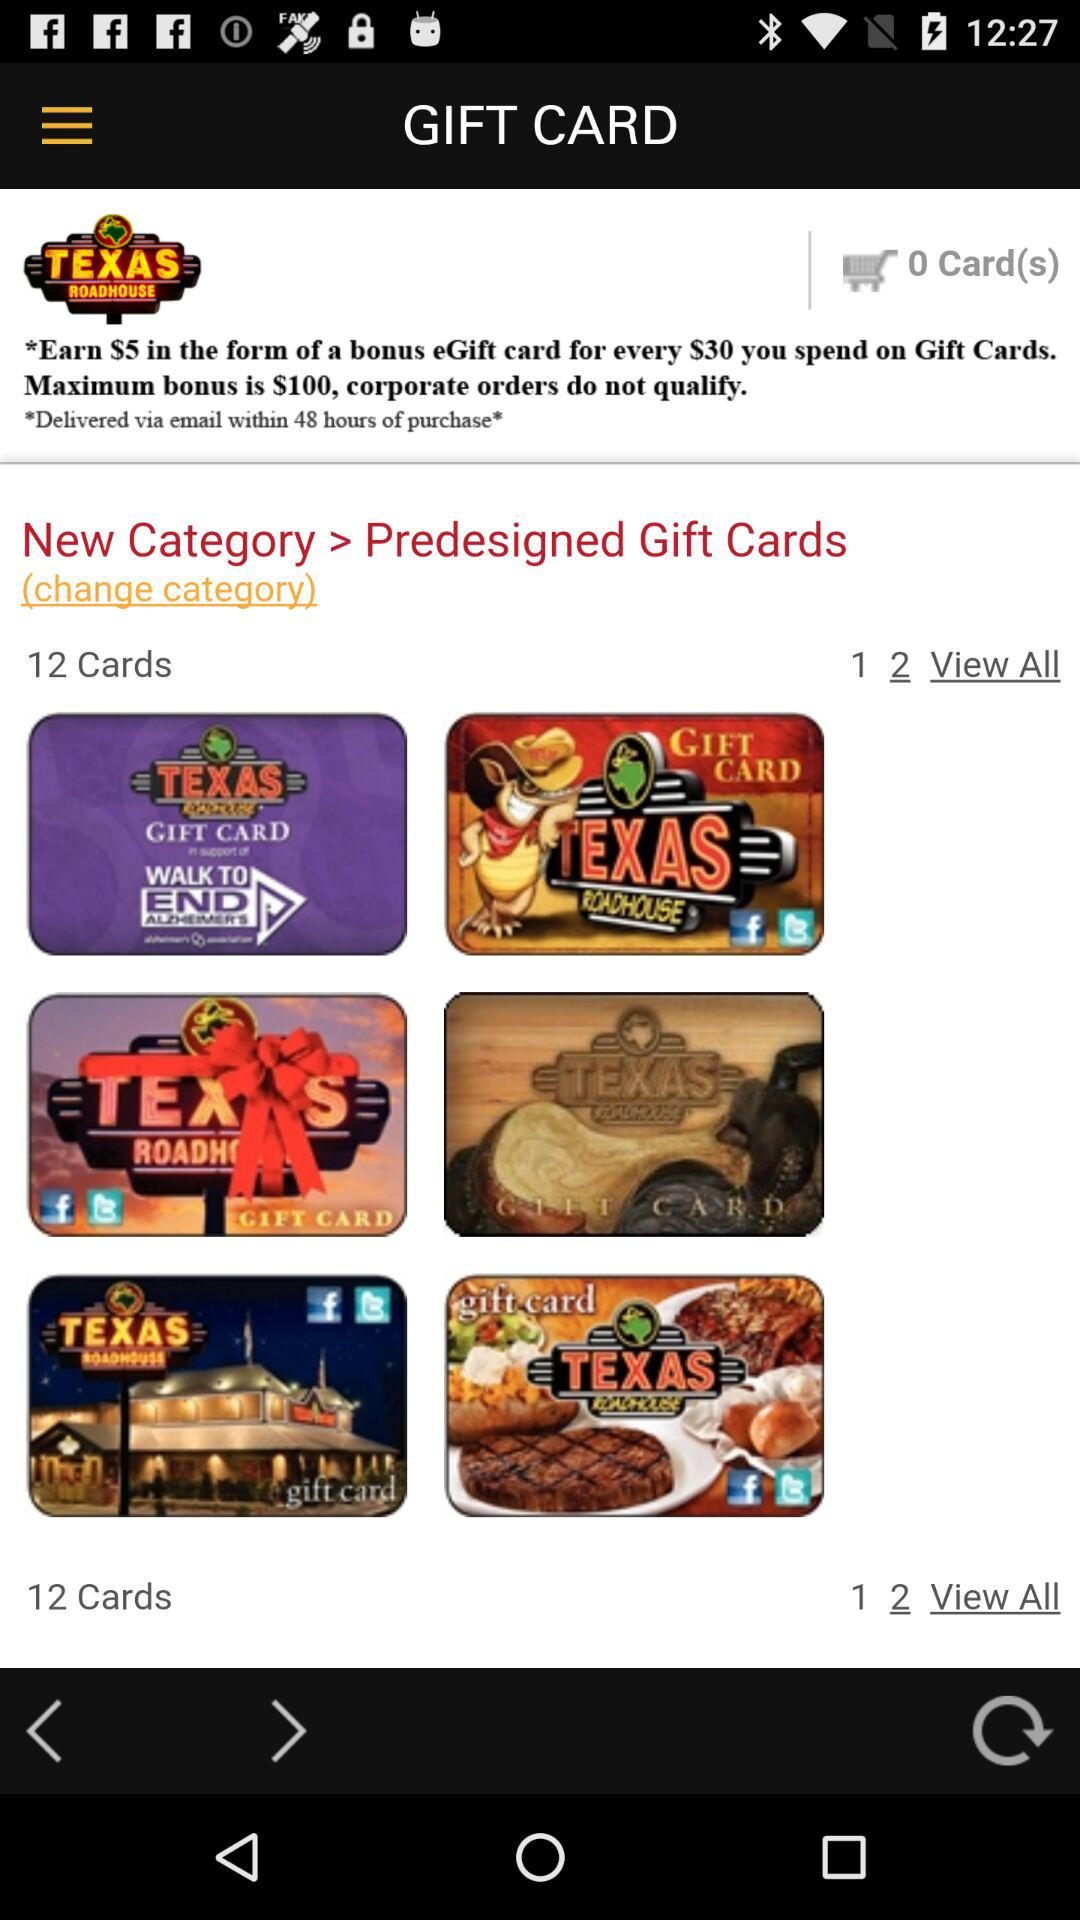How many items are available in the cart? There are 0 available items. 